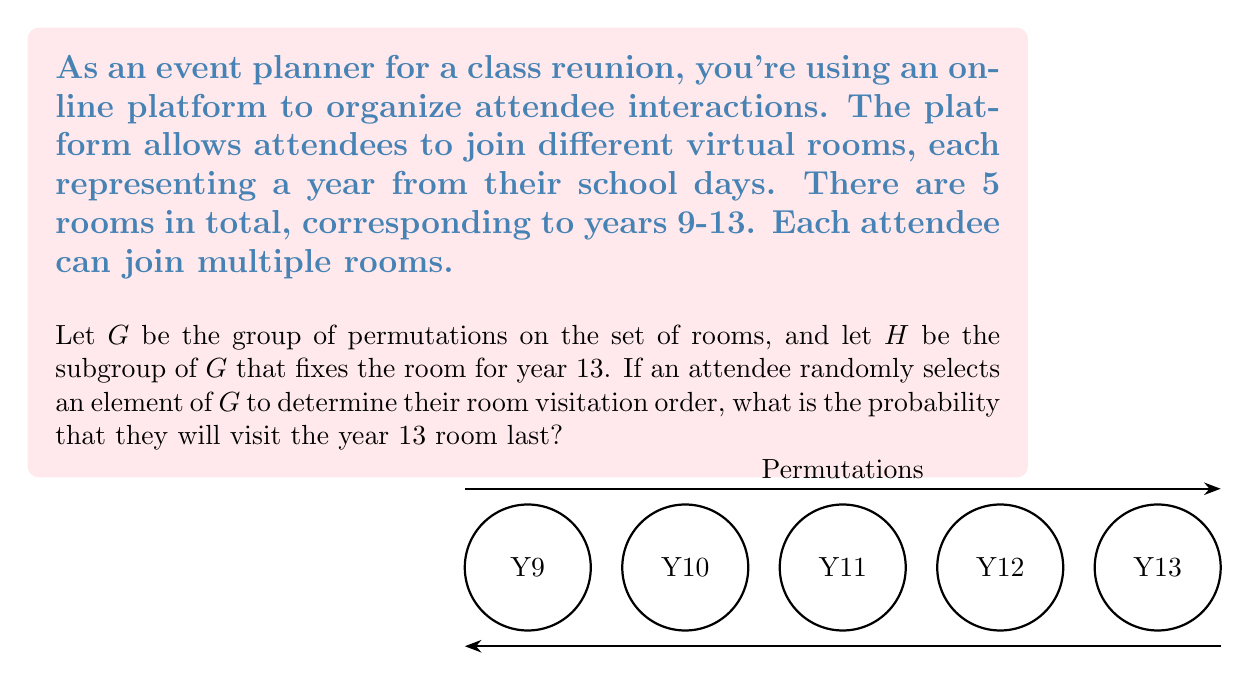Could you help me with this problem? Let's approach this step-by-step:

1) First, we need to understand what the group $G$ and subgroup $H$ represent:
   - $G$ is the group of all permutations of the 5 rooms. Its order is $|G| = 5! = 120$.
   - $H$ is the subgroup that fixes the year 13 room, meaning it contains all permutations of the other 4 rooms. Its order is $|H| = 4! = 24$.

2) The question is essentially asking for the probability that a randomly chosen element of $G$ ends with the year 13 room.

3) In group theory, this is equivalent to finding the index of $H$ in $G$, denoted as $[G:H]$. The index represents the number of distinct left (or right) cosets of $H$ in $G$.

4) We can calculate this using Lagrange's theorem:

   $$[G:H] = \frac{|G|}{|H|} = \frac{5!}{4!} = 5$$

5) This means there are 5 distinct cosets of $H$ in $G$, each corresponding to one of the 5 possible positions for the year 13 room in the permutation.

6) Since we want the probability of the year 13 room being last, we're interested in just one of these 5 cosets.

7) Therefore, the probability is:

   $$P(\text{Year 13 last}) = \frac{1}{[G:H]} = \frac{1}{5} = 0.2$$
Answer: $\frac{1}{5}$ or $0.2$ or $20\%$ 